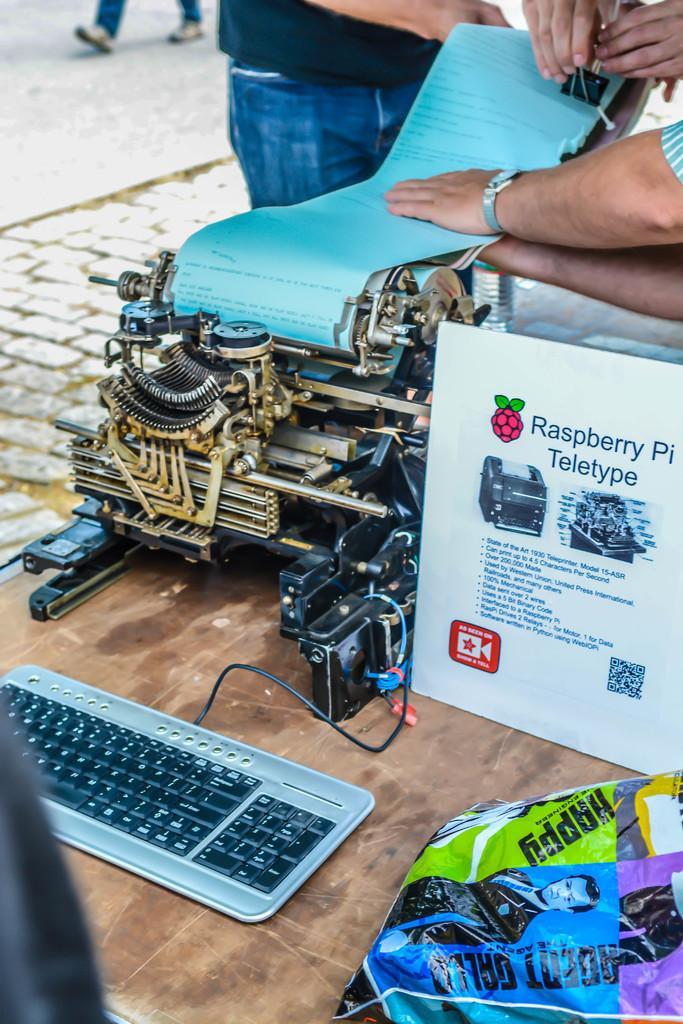Describe this image in one or two sentences. In the center of the image we can see a table. On the table we can see a printing machine, board, keyboard, screen, plastic cover. At the top of the image we can see the road and three people are standing and two people are holding the paper and the object and also we can see a person is walking on the road. 